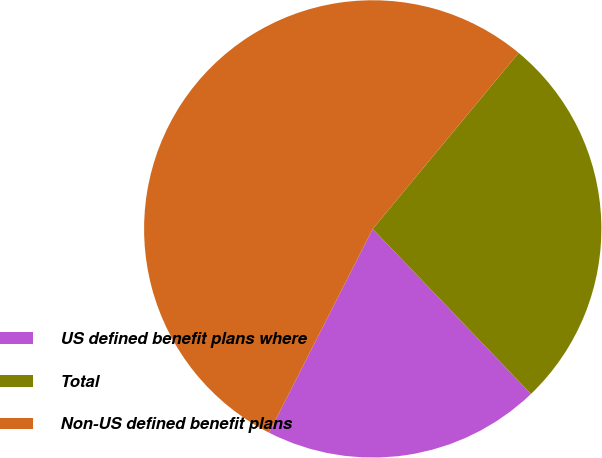Convert chart to OTSL. <chart><loc_0><loc_0><loc_500><loc_500><pie_chart><fcel>US defined benefit plans where<fcel>Total<fcel>Non-US defined benefit plans<nl><fcel>19.66%<fcel>26.82%<fcel>53.53%<nl></chart> 